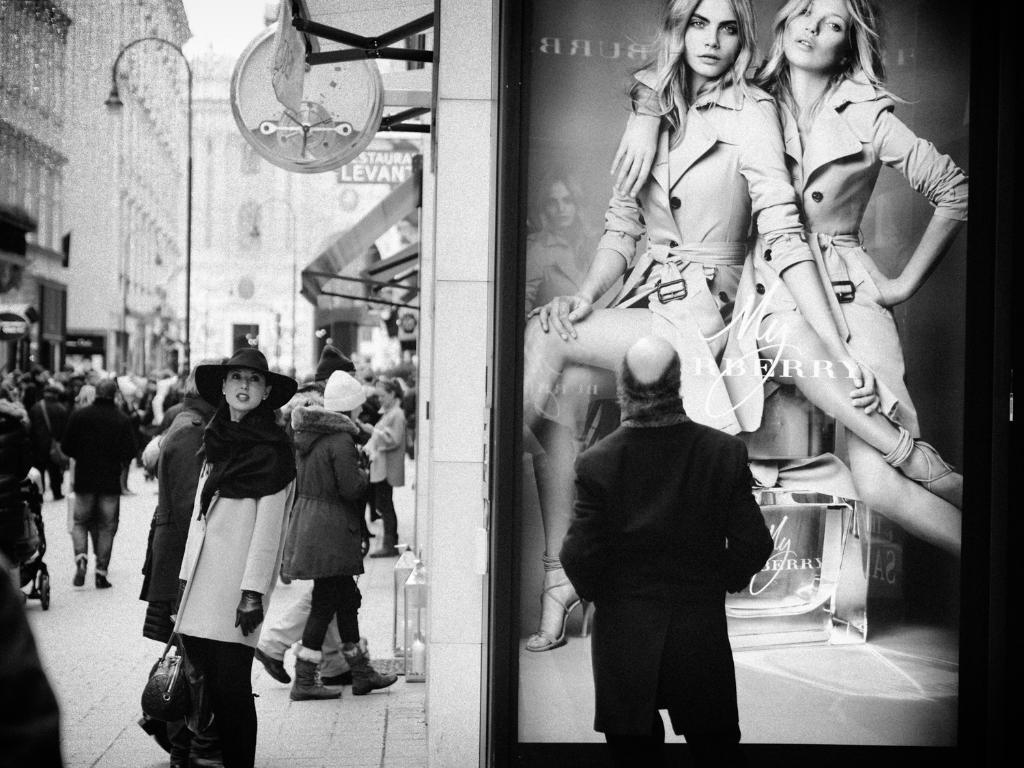What is the person in the image wearing? There is a person wearing a black dress in the image. What is the person standing in front of? The person is standing in front of a picture. Where are the other people located in the image? There are people standing in the left corner of the image. What can be seen in the distance in the image? There are buildings in the background of the image. What type of bath is the person taking in the image? There is no bath present in the image; the person is standing in front of a picture. 